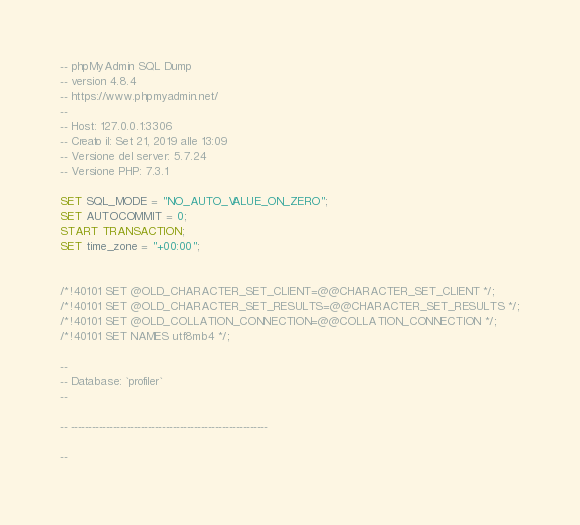Convert code to text. <code><loc_0><loc_0><loc_500><loc_500><_SQL_>-- phpMyAdmin SQL Dump
-- version 4.8.4
-- https://www.phpmyadmin.net/
--
-- Host: 127.0.0.1:3306
-- Creato il: Set 21, 2019 alle 13:09
-- Versione del server: 5.7.24
-- Versione PHP: 7.3.1

SET SQL_MODE = "NO_AUTO_VALUE_ON_ZERO";
SET AUTOCOMMIT = 0;
START TRANSACTION;
SET time_zone = "+00:00";


/*!40101 SET @OLD_CHARACTER_SET_CLIENT=@@CHARACTER_SET_CLIENT */;
/*!40101 SET @OLD_CHARACTER_SET_RESULTS=@@CHARACTER_SET_RESULTS */;
/*!40101 SET @OLD_COLLATION_CONNECTION=@@COLLATION_CONNECTION */;
/*!40101 SET NAMES utf8mb4 */;

--
-- Database: `profiler`
--

-- --------------------------------------------------------

--</code> 